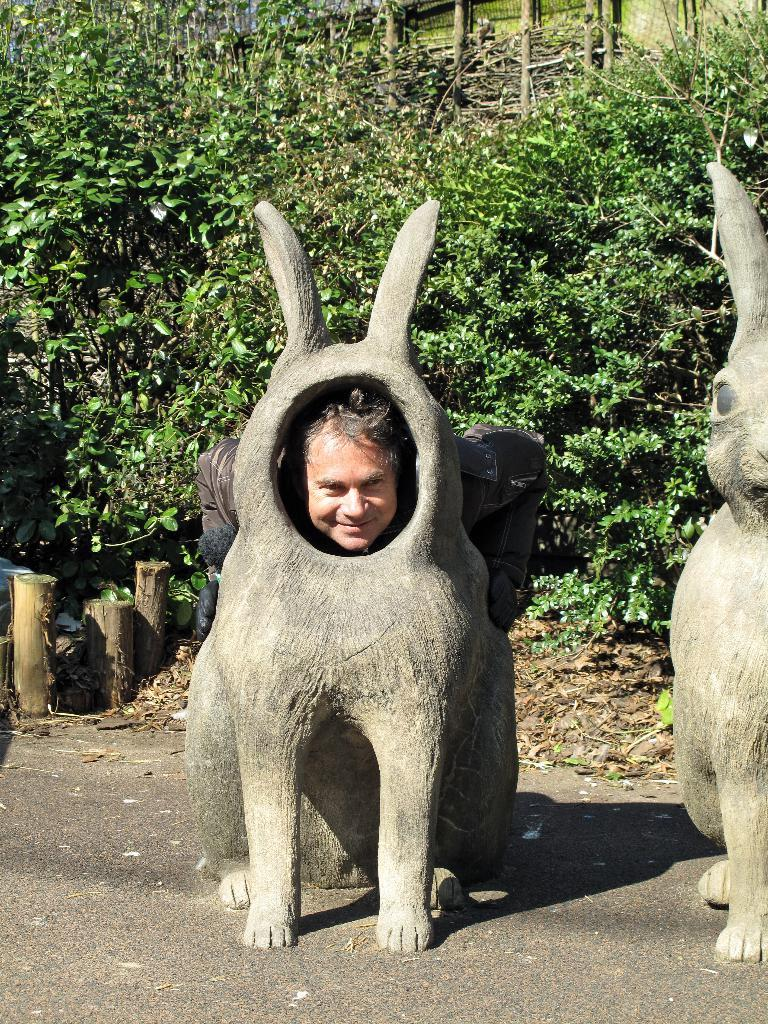What object is located on the right side of the image? There is a rabbit statue on the right side of the image. What is unique about the rabbit statue? There is a man inside the rabbit statue in the center. What type of vegetation can be seen in the background of the image? There is greenery in the background of the image. What type of plants are on the left side of the image? There are small bamboos on the left side of the image. What type of locket is the man wearing around his neck in the image? There is no man wearing a locket around his neck in the image; the man is inside the rabbit statue. How many trays can be seen on the table in the image? There is no table or tray present in the image. 